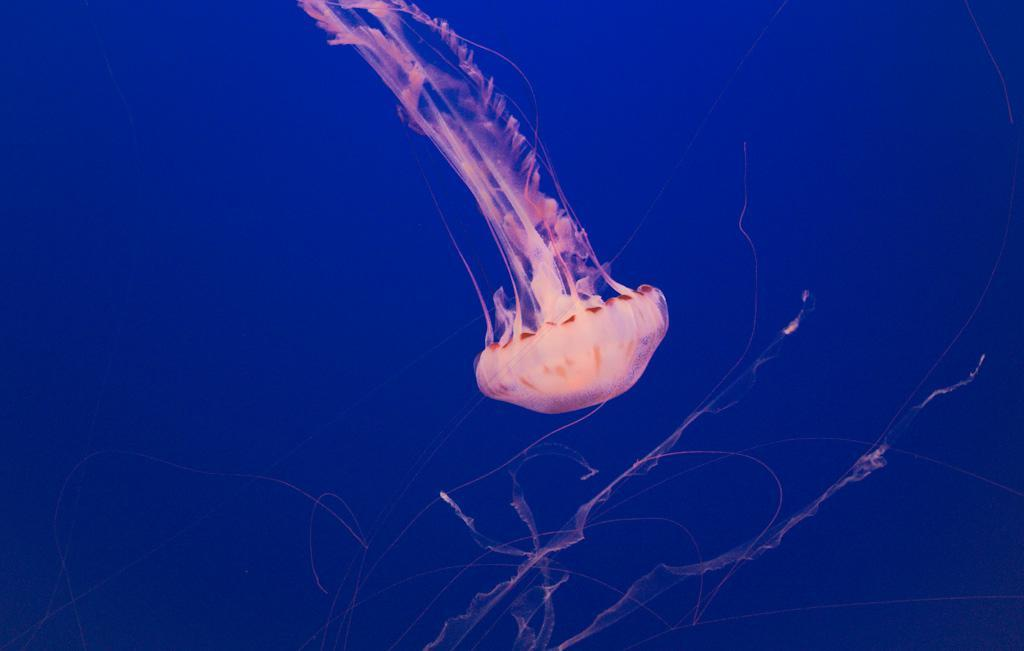What is the main subject of the image? There is a jellyfish in the image. What color is the background of the image? The background of the image is blue. Is the existence of the jellyfish in the image confirmed by the presence of a parcel? There is no mention of a parcel in the image, and the presence of a jellyfish is confirmed by the facts provided. 